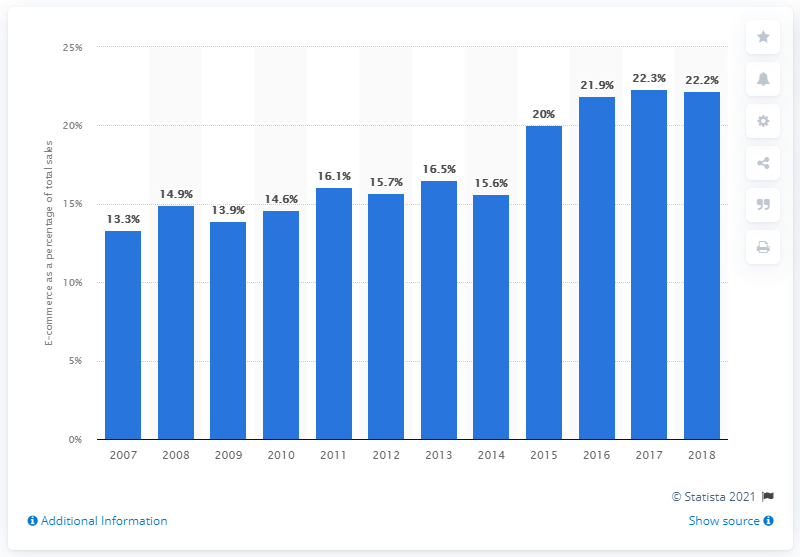Point out several critical features in this image. In the prior year, e-commerce accounted for 22.2% of total furniture wholesale trade. E-commerce accounted for 22.2% of furniture wholesale trade in 2018. 